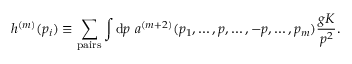<formula> <loc_0><loc_0><loc_500><loc_500>h ^ { ( m ) } ( p _ { i } ) \equiv \sum _ { p a i r s } \int d p \ a ^ { ( m + 2 ) } ( p _ { 1 } , \dots , p , \dots , - p , \dots , p _ { m } ) { \frac { g K } { p ^ { 2 } } } .</formula> 